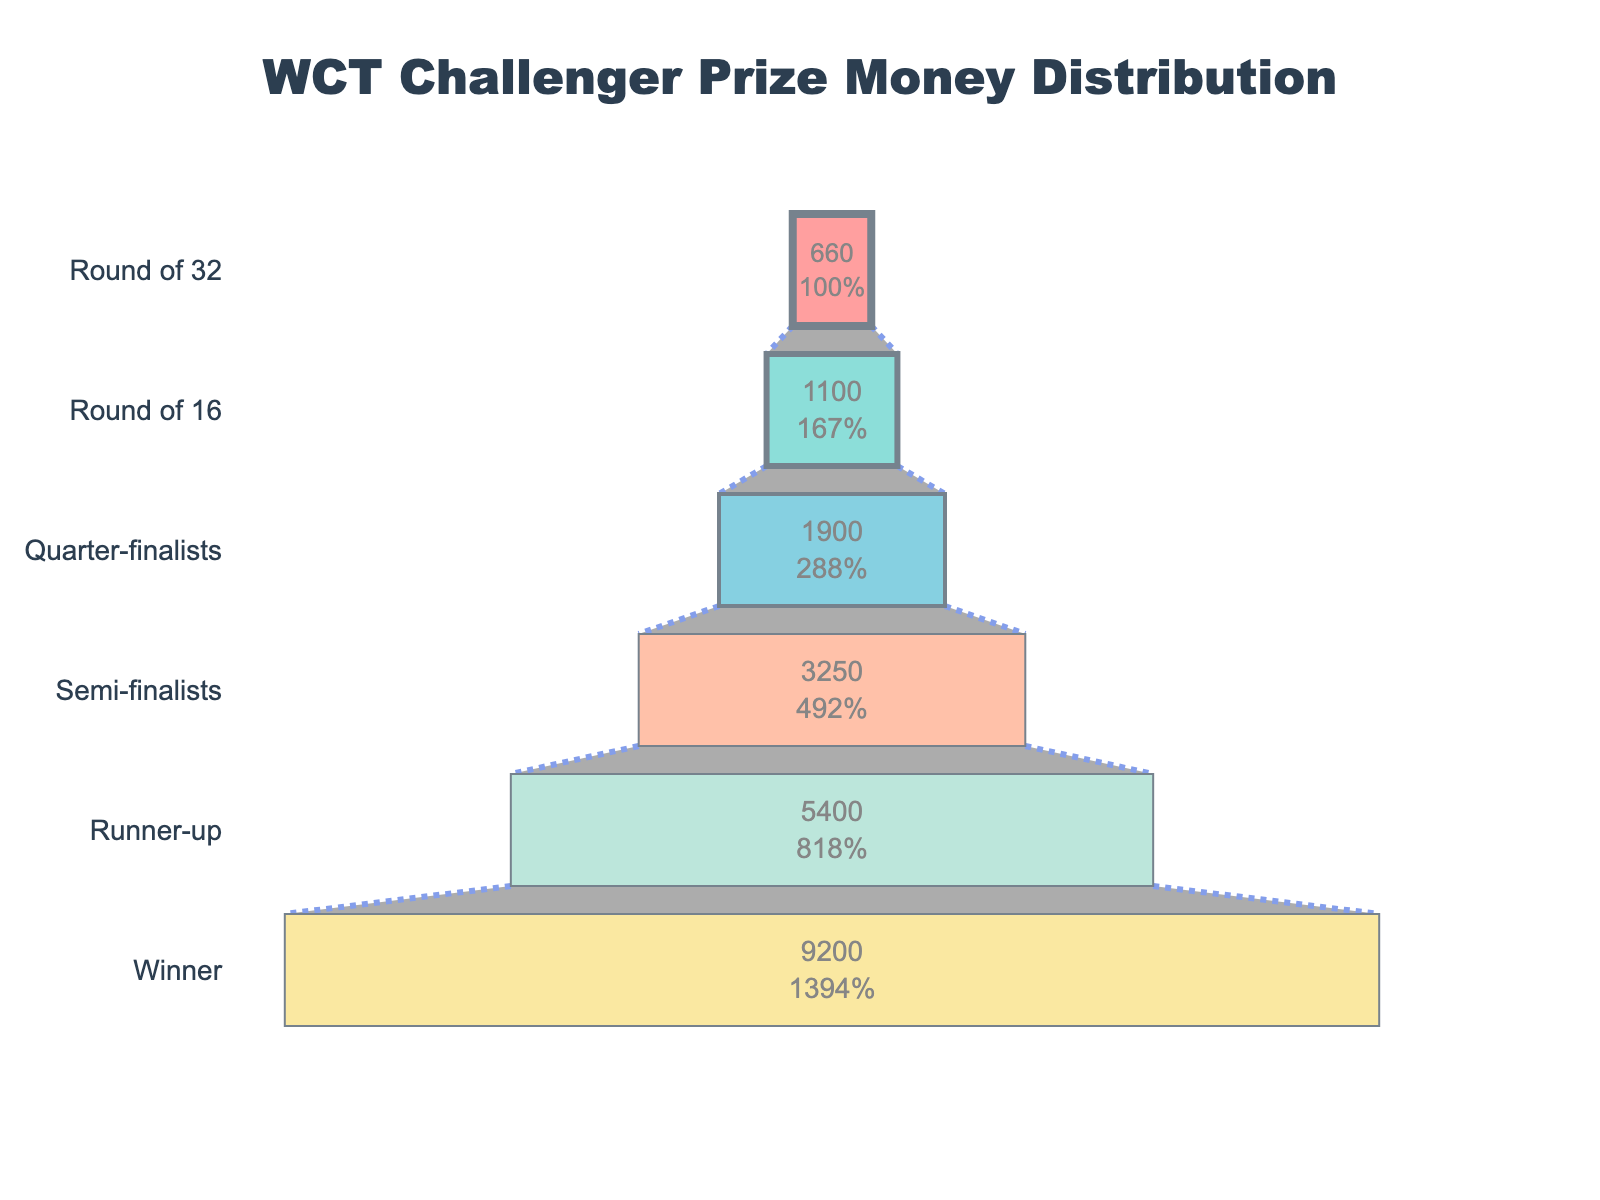What is the total prize money for the winner? To find the prize money for the winner, look for the "Winner" section in the funnel chart. The amount listed there is the total prize money for the winner.
Answer: 9200 € What is the percentage decrease in prize money from the Winner to the Runner-up? First, find the prize amounts for the Winner (9200 €) and the Runner-up (5400 €). Calculate the difference: 9200 € - 5400 € = 3800 €. Then, divide the difference by the Winner's amount, and multiply by 100 to get the percentage: (3800 / 9200) * 100 ≈ 41.3%.
Answer: 41.3% Which round has the lowest prize money, and what is the amount? Look at the funnel chart and identify the segment with the smallest length along the x-axis, which corresponds to the lowest prize money. The label for that segment shows the round and the amount.
Answer: Round of 32, 660 € How does the prize money change from the Round of 16 to the Quarter-finalists? Identify the prize money for both the Round of 16 (1100 €) and the Quarter-finalists (1900 €). Calculate the difference to see the change: 1900 € - 1100 € = 800 €.
Answer: Increases by 800 € What's the sum of the prize money given to Semi-finalists and Quarter-finalists? Find the prize money for Semi-finalists (3250 € each) and Quarter-finalists (1900 € each). Since there are two Semi-finalists and four Quarter-finalists, the total is: (2 * 3250) + (4 * 1900) = 6500 + 7600 = 14100 €.
Answer: 14100 € For which round is the prize money 3250 €? Locate the segment in the funnel chart that corresponds to 3250 €. The label next to this segment indicates the round.
Answer: Semi-finalists What is the average prize money for the rounds from Round of 32 to Quarter-finalists? Identify the prize money for the Round of 32 (660 €), Round of 16 (1100 €), and Quarter-finalists (1900 €). Calculate the average: (660 € + 1100 € + 1900 €) / 3 = 3660 € / 3 ≈ 1220 €.
Answer: 1220 € What proportion of the total prize money is awarded to the winner? First, sum the prize money of all rounds: 9200 € + 5400 € + 3250 € + 1900 € + 1100 € + 660 € = 21510 €. Then, divide the winner's prize by the total and multiply by 100: (9200 / 21510) * 100 ≈ 42.8%.
Answer: 42.8% Which two rounds have the closest prize money amounts, and what is the difference? Compare the prize money for each round. The closest amounts are 1100 € (Round of 16) and 660 € (Round of 32). The difference is: 1100 € - 660 € = 440 €.
Answer: Round of 16 and Round of 32, 440 € How much more is the total prize money for the semi-finalists compared to the round prior (Quarter-finalists)? Calculate the total prize money for Semi-finalists (2 * 3250 = 6500 €) and Quarter-finalists (4 * 1900 = 7600 €). Then, find the difference between these sums: 7600 € - 6500 € = 1100 €.
Answer: 1100 € 